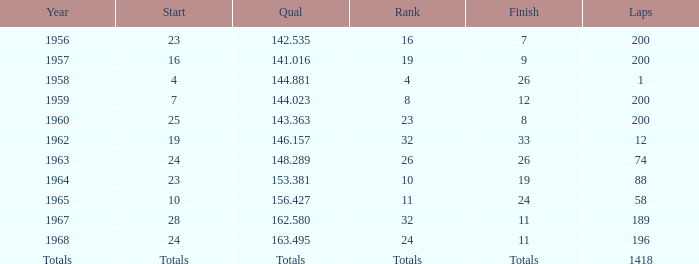What is the highest number of laps that also has a finish total of 8? 200.0. 